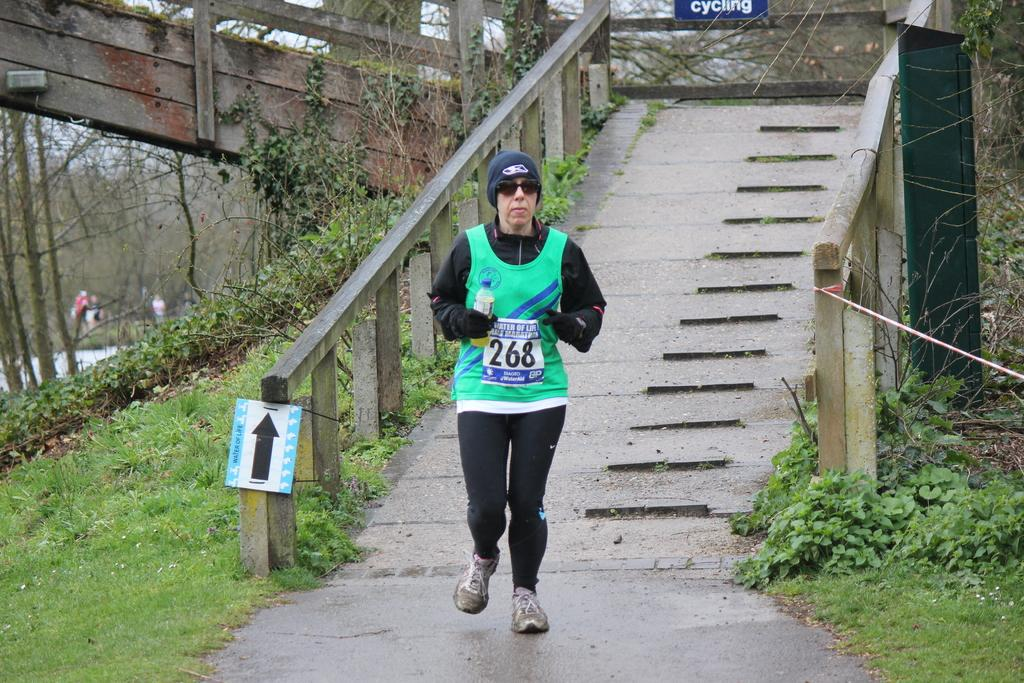What is the person in the image doing? The person is running in the image. What is the person holding while running? The person is holding an object. What can be seen in the background of the image? The sky is visible in the background of the image. What type of vegetation is present in the image? Trees and grass are visible in the image. What is on the right side of the image? There is an object on the right side of the image. What is the person running near in the image? There is a bridge railing in the image. How many marbles are visible on the person's head in the image? There are no marbles visible on the person's head in the image. What type of men can be seen interacting with the person running in the image? There is no mention of any men in the image; it only features a person running. 